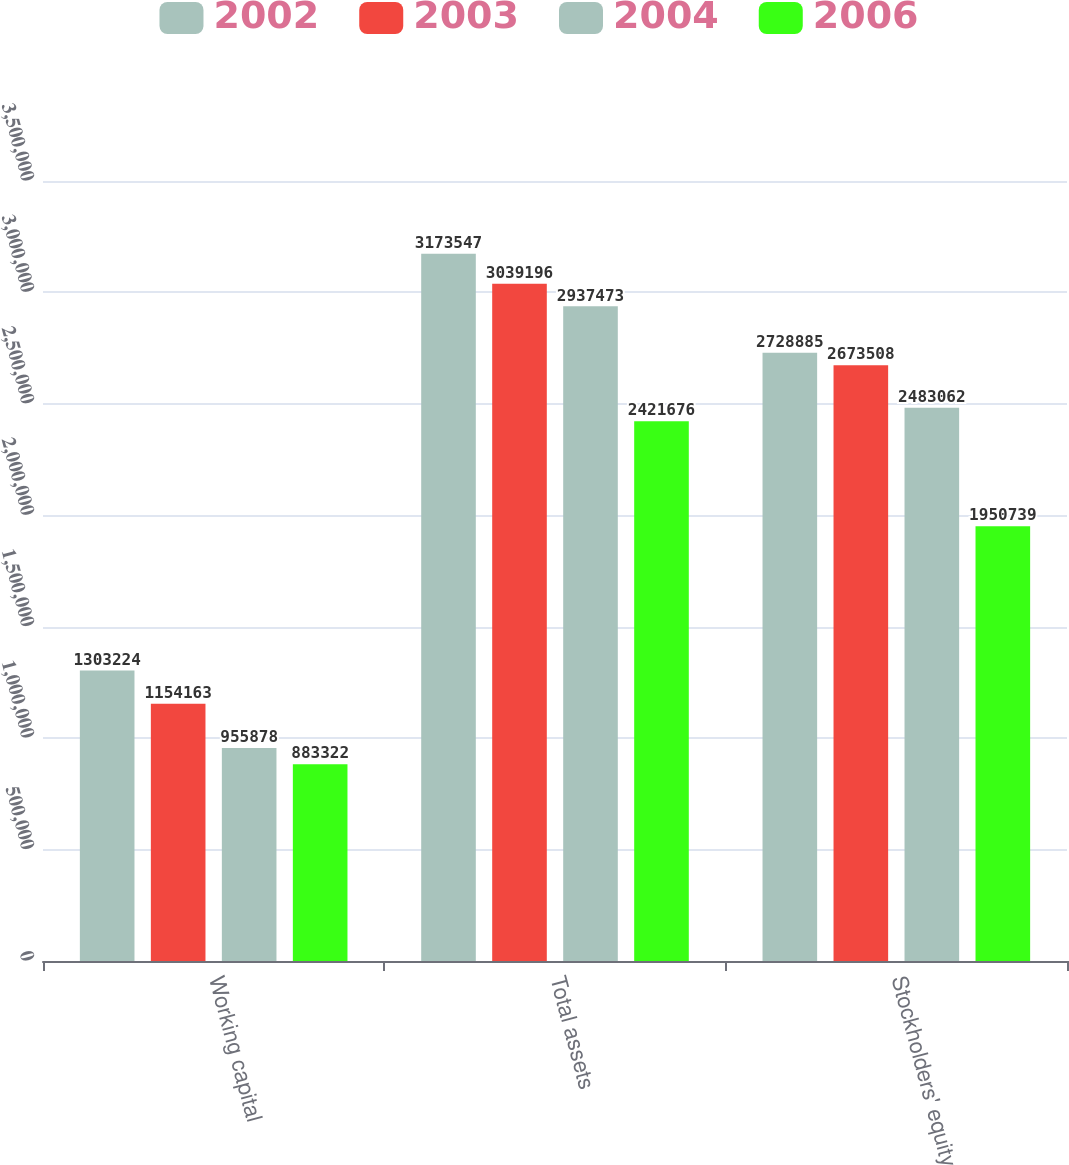<chart> <loc_0><loc_0><loc_500><loc_500><stacked_bar_chart><ecel><fcel>Working capital<fcel>Total assets<fcel>Stockholders' equity<nl><fcel>2002<fcel>1.30322e+06<fcel>3.17355e+06<fcel>2.72888e+06<nl><fcel>2003<fcel>1.15416e+06<fcel>3.0392e+06<fcel>2.67351e+06<nl><fcel>2004<fcel>955878<fcel>2.93747e+06<fcel>2.48306e+06<nl><fcel>2006<fcel>883322<fcel>2.42168e+06<fcel>1.95074e+06<nl></chart> 